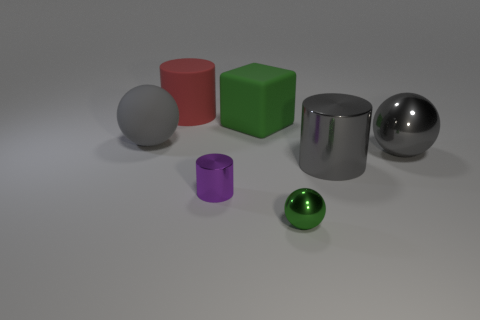There is a rubber sphere that is the same size as the gray cylinder; what is its color?
Offer a very short reply. Gray. What number of other objects are there of the same shape as the tiny purple object?
Provide a short and direct response. 2. Is the cube the same size as the green ball?
Ensure brevity in your answer.  No. Is the number of large balls that are behind the big red matte cylinder greater than the number of big gray matte balls that are behind the small green object?
Provide a succinct answer. No. What number of other things are the same size as the green ball?
Provide a short and direct response. 1. There is a cylinder right of the small ball; does it have the same color as the small shiny cylinder?
Provide a short and direct response. No. Is the number of small objects right of the big gray metallic ball greater than the number of purple objects?
Your answer should be very brief. No. Are there any other things that have the same color as the matte ball?
Ensure brevity in your answer.  Yes. There is a green thing that is in front of the large gray thing left of the tiny purple metal cylinder; what shape is it?
Ensure brevity in your answer.  Sphere. Are there more tiny metal cylinders than gray metallic things?
Offer a very short reply. No. 